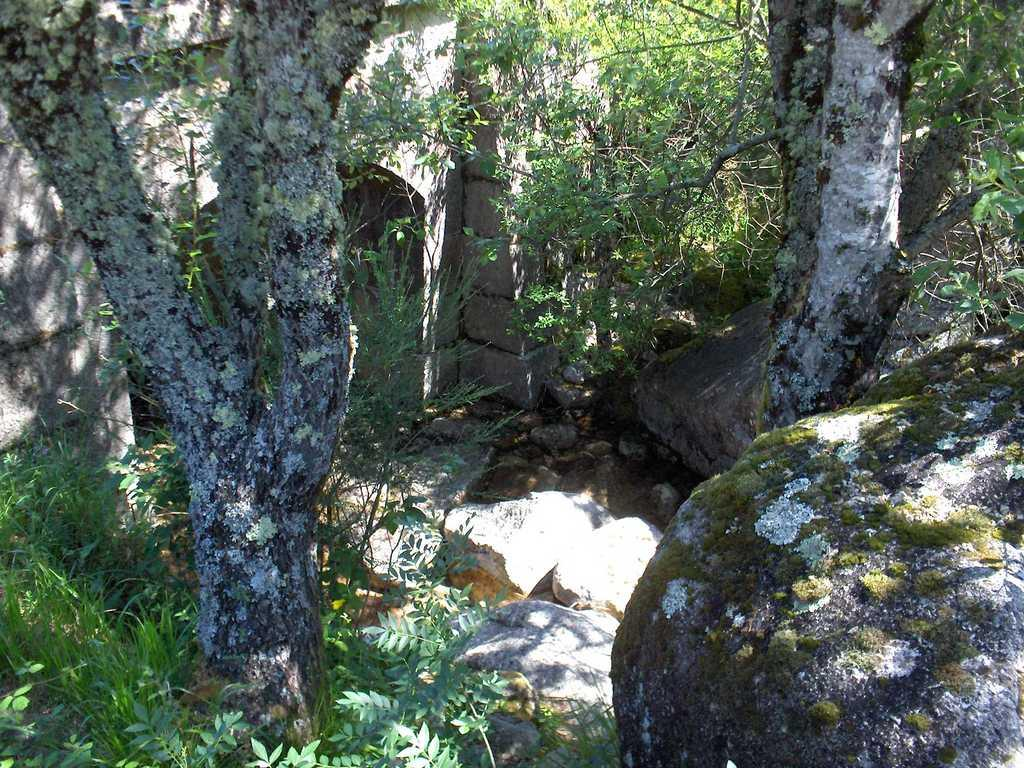What is the main feature of the image? The main feature of the image is the bark of a tree. What other natural elements can be seen in the image? There are plants, grass, stones, and trees in the image. Are there any man-made structures visible in the image? Yes, there is a wall in the image. What type of band is playing near the gate in the image? There is no band or gate present in the image. 